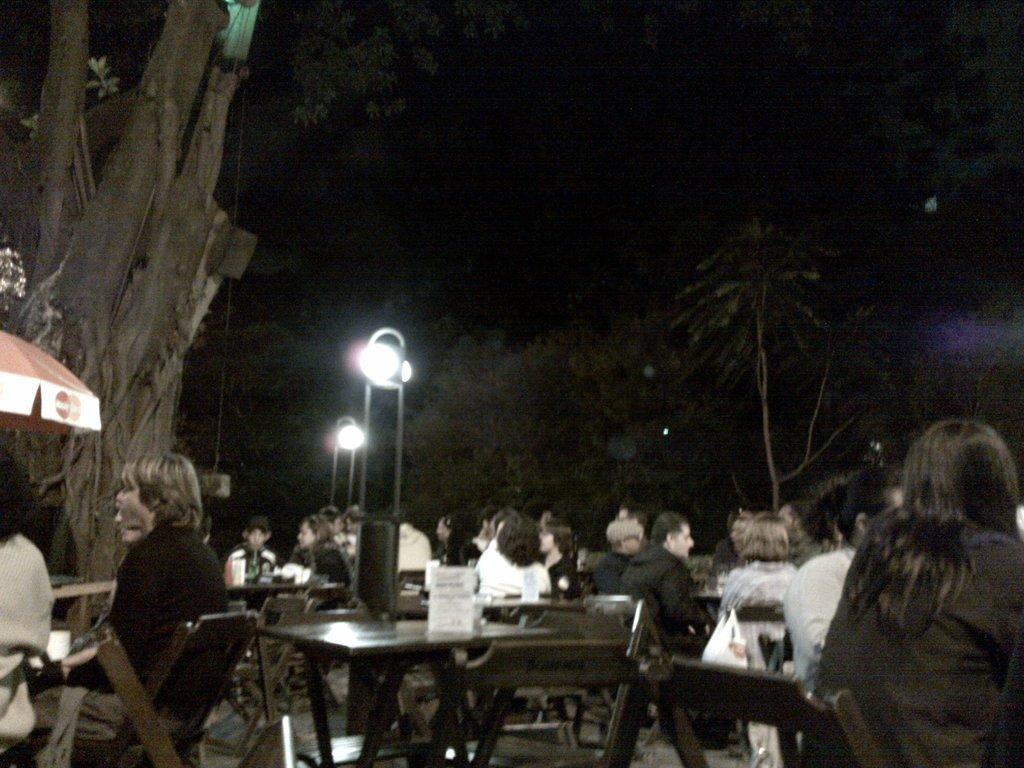Please provide a concise description of this image. In this picture we can see a group of people sitting on chair and in front of them there is table and on table we can see some box type material and in background we can see tree, pole, light and it is dark. 